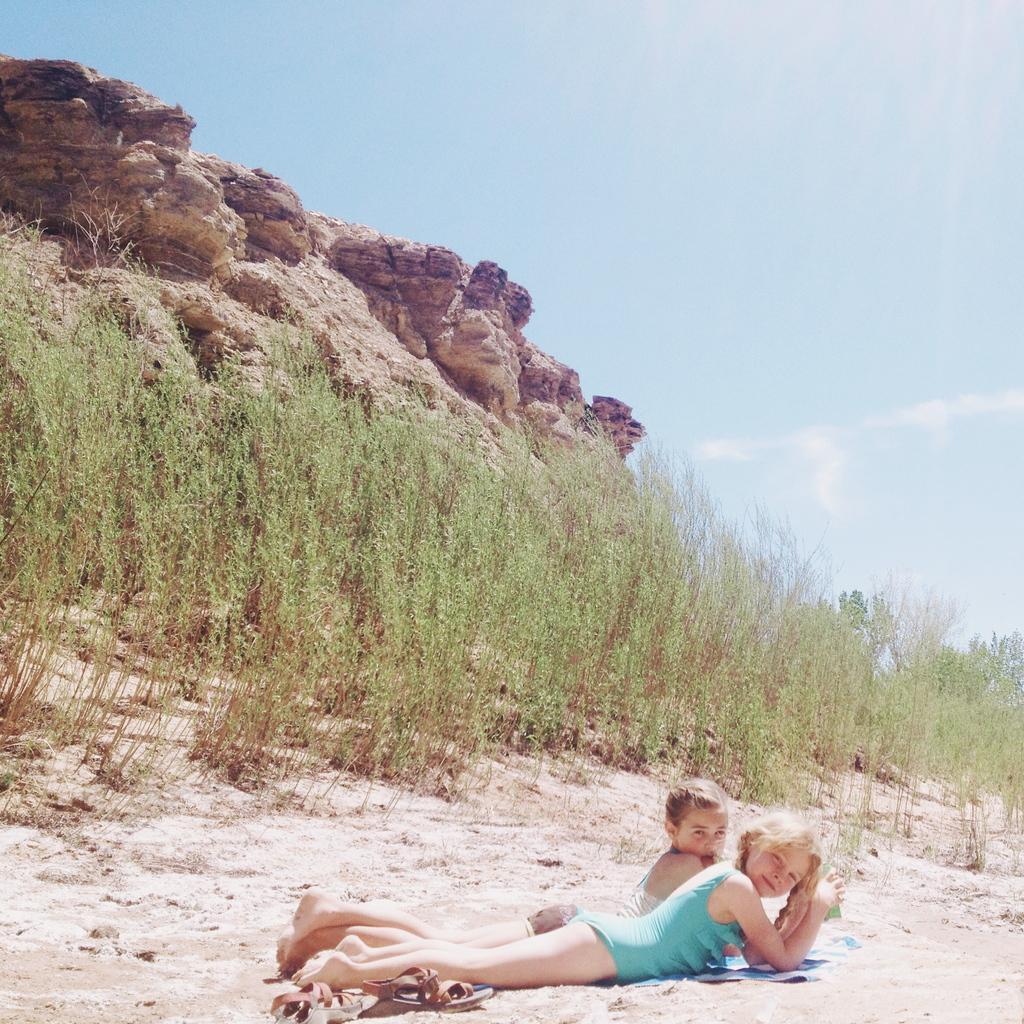Could you give a brief overview of what you see in this image? At the bottom of the image there are two girls lying on the sand. In the background of the image there are rocks, plants. At the top of the image there is sky. 